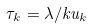<formula> <loc_0><loc_0><loc_500><loc_500>\tau _ { k } = \lambda / k u _ { k }</formula> 